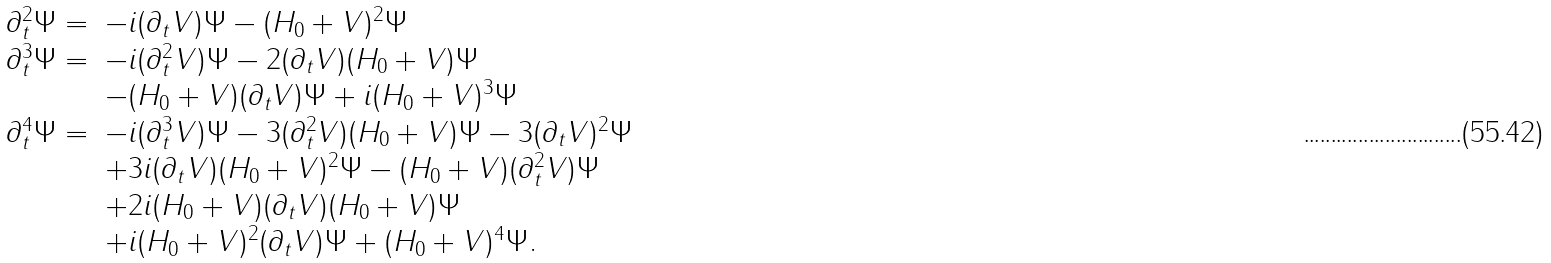<formula> <loc_0><loc_0><loc_500><loc_500>\begin{array} { l l } \partial _ { t } ^ { 2 } \Psi = & - i ( \partial _ { t } V ) \Psi - ( H _ { 0 } + V ) ^ { 2 } \Psi \\ \partial _ { t } ^ { 3 } \Psi = & - i ( \partial _ { t } ^ { 2 } V ) \Psi - 2 ( \partial _ { t } V ) ( H _ { 0 } + V ) \Psi \\ & - ( H _ { 0 } + V ) ( \partial _ { t } V ) \Psi + i ( H _ { 0 } + V ) ^ { 3 } \Psi \\ \partial _ { t } ^ { 4 } \Psi = & - i ( \partial _ { t } ^ { 3 } V ) \Psi - 3 ( \partial _ { t } ^ { 2 } V ) ( H _ { 0 } + V ) \Psi - 3 ( \partial _ { t } V ) ^ { 2 } \Psi \\ & + 3 i ( \partial _ { t } V ) ( H _ { 0 } + V ) ^ { 2 } \Psi - ( H _ { 0 } + V ) ( \partial _ { t } ^ { 2 } V ) \Psi \\ & + 2 i ( H _ { 0 } + V ) ( \partial _ { t } V ) ( H _ { 0 } + V ) \Psi \\ & + i ( H _ { 0 } + V ) ^ { 2 } ( \partial _ { t } V ) \Psi + ( H _ { 0 } + V ) ^ { 4 } \Psi . \end{array}</formula> 